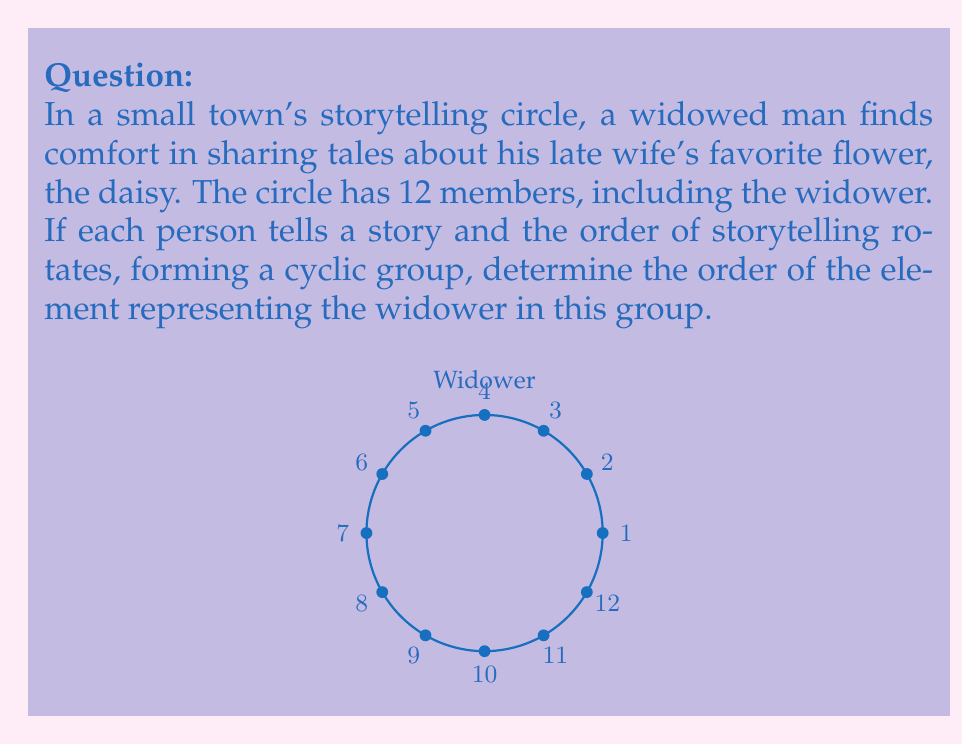Show me your answer to this math problem. To determine the order of an element in a cyclic group, we need to find the smallest positive integer $k$ such that $a^k = e$, where $a$ is the element and $e$ is the identity element.

In this case:
1) The group has 12 elements, representing the 12 members of the storytelling circle.
2) The widower's position in the rotation can be represented as the generator of the group, let's call it $a$.
3) We need to find the smallest $k$ such that $a^k = e$ (i.e., returns to the starting position).

Since the group has 12 elements:
$$a^{12} = e$$

This means that after 12 rotations, we return to the starting position. However, we need to check if there's a smaller $k$ that satisfies this condition.

Possible factors of 12 are: 1, 2, 3, 4, 6, 12

We can eliminate 1 immediately as it would mean the widower doesn't move.

$a^2$: Moves to position 3, not back to start.
$a^3$: Moves to position 4, not back to start.
$a^4$: Moves to position 5, not back to start.
$a^6$: Moves to position 7, not back to start.
$a^{12}$: Returns to the starting position.

Therefore, the smallest $k$ that satisfies $a^k = e$ is 12.
Answer: 12 